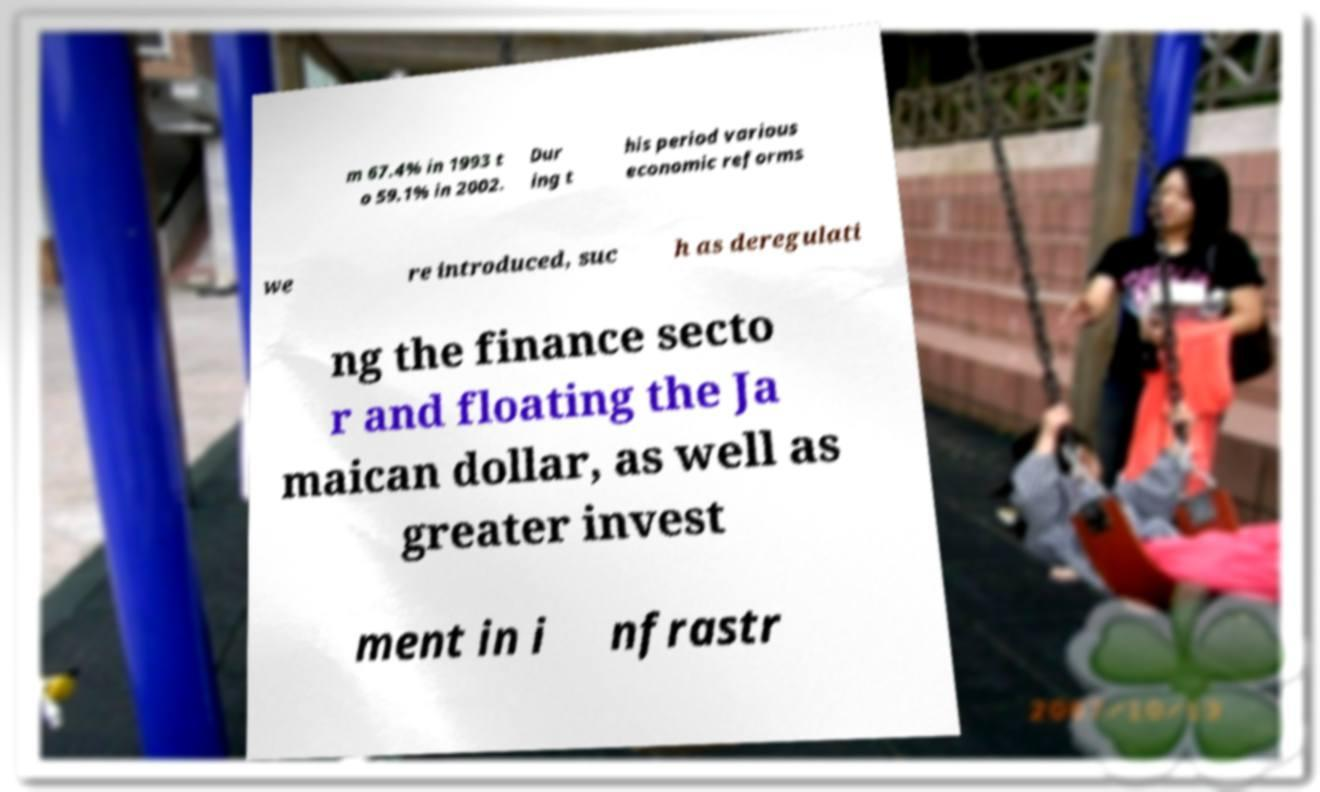Could you extract and type out the text from this image? m 67.4% in 1993 t o 59.1% in 2002. Dur ing t his period various economic reforms we re introduced, suc h as deregulati ng the finance secto r and floating the Ja maican dollar, as well as greater invest ment in i nfrastr 